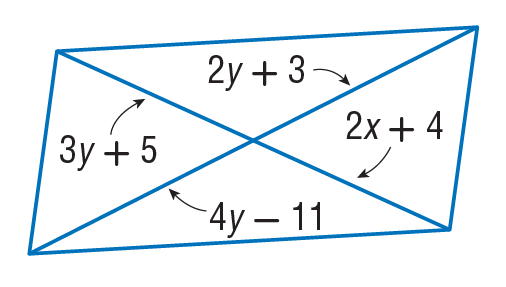Question: Find x so that the quadrilateral is a parallelogram.
Choices:
A. 11
B. 25
C. 26
D. 33
Answer with the letter. Answer: A 